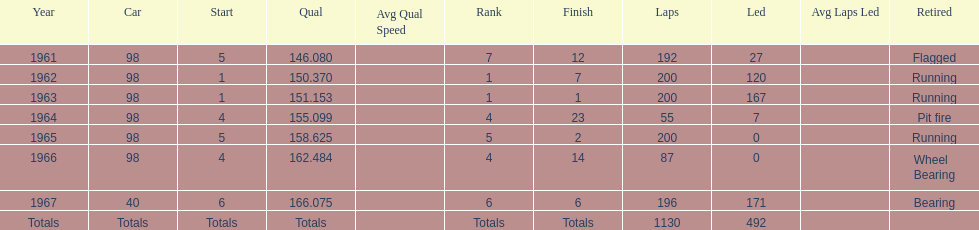How many times did he finish in the top three? 2. 